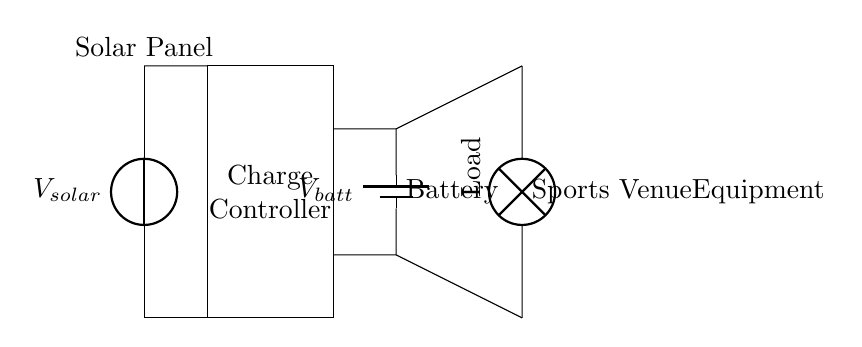What is the primary energy source for this circuit? The primary energy source is the solar panel, which converts sunlight into electrical energy.
Answer: Solar panel What component controls the charging of the battery? The charge controller is responsible for managing the charging process of the battery, ensuring that it does not overcharge or discharge too much.
Answer: Charge controller How many batteries are depicted in this circuit? The circuit diagram shows one battery symbol, indicating that there is a single battery in the system.
Answer: One What is the function of the load in this circuit? The load represents the sports venue equipment that utilizes the stored energy from the battery to operate its functions.
Answer: Equipment Which component connects the solar panel and the charge controller? A short connection is illustrated between the solar panel and the charge controller, indicating direct electrical connection.
Answer: Short connection What is the expected output from the battery to the load? The output from the battery to the load is represented by the voltage V_batt, which powers the sports venue equipment.
Answer: V_batt How does the charge controller protect the battery? The charge controller regulates voltage and current to prevent overcharging and excessive discharge, thereby protecting battery life.
Answer: Regulation 